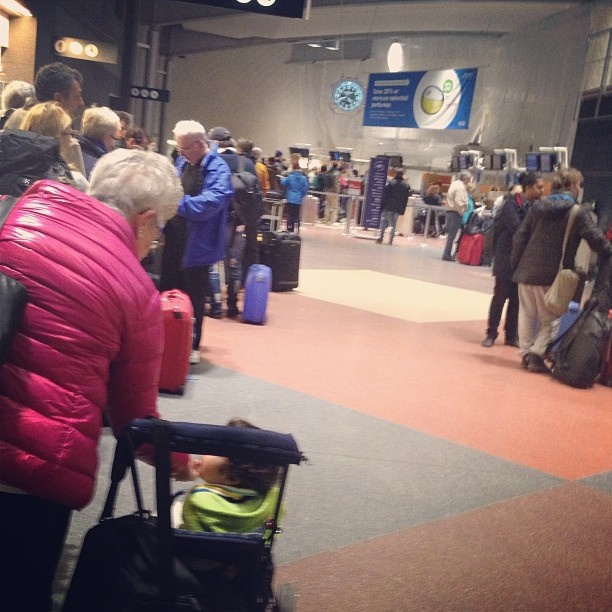Describe the objects in this image and their specific colors. I can see people in lightgray, maroon, black, brown, and violet tones, suitcase in lightgray, black, gray, darkgray, and darkgreen tones, people in lightgray, black, gray, and darkgray tones, people in lightgray, gray, and black tones, and people in lightgray, black, navy, and purple tones in this image. 